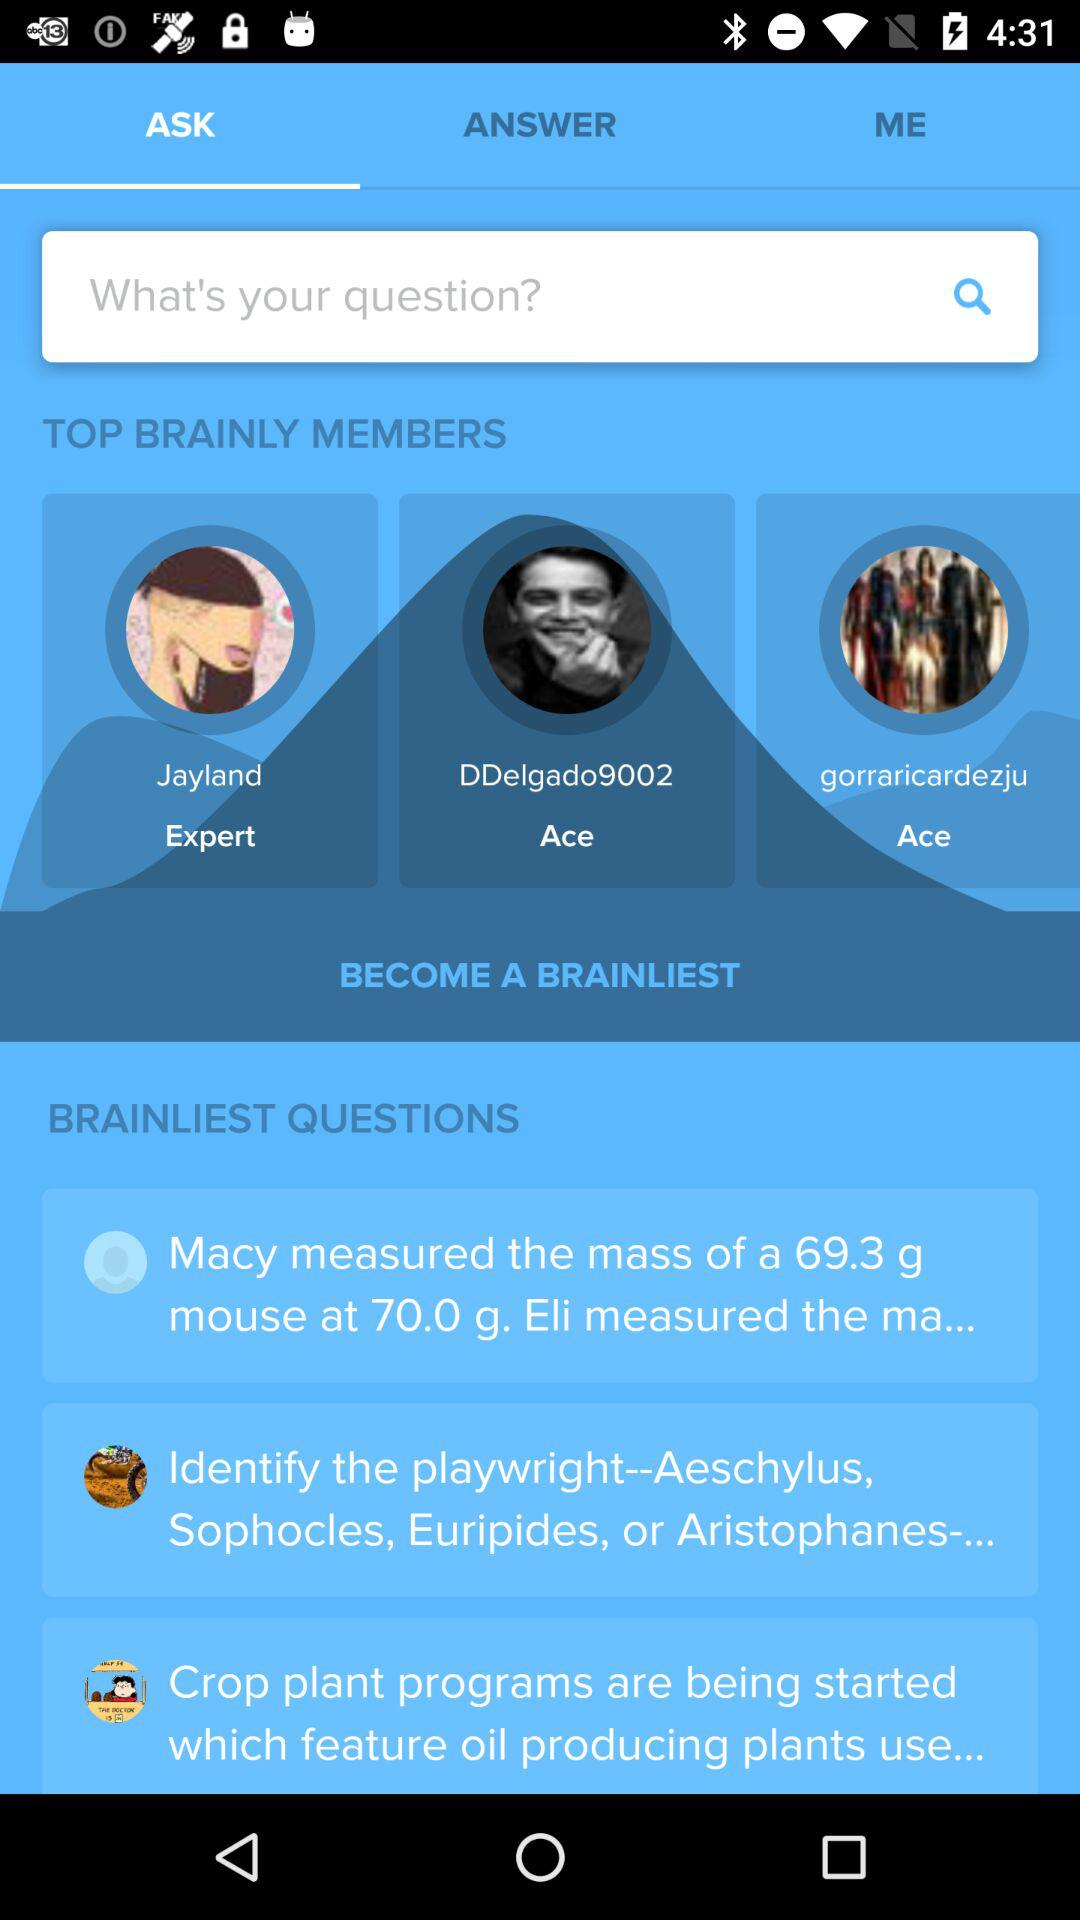What are the names of the top "BRAINLY" members? The names of the top "BRAINLY" members are "Jayland", "DDelgado9002" and "gorraricardezju". 